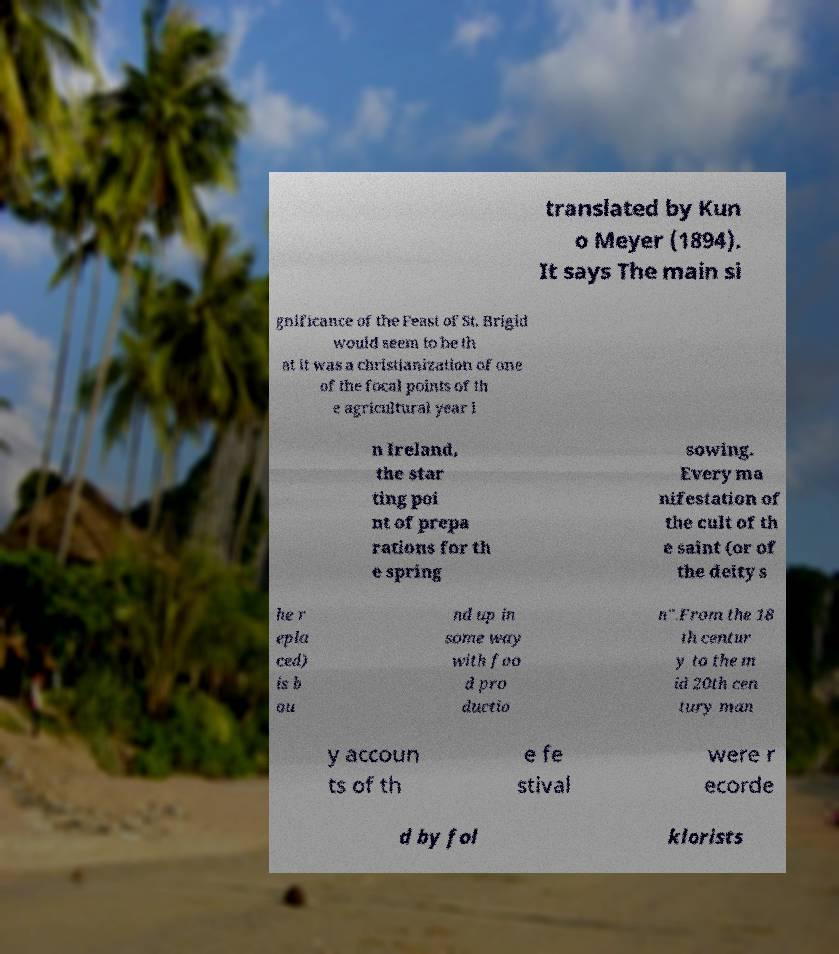I need the written content from this picture converted into text. Can you do that? translated by Kun o Meyer (1894). It says The main si gnificance of the Feast of St. Brigid would seem to be th at it was a christianization of one of the focal points of th e agricultural year i n Ireland, the star ting poi nt of prepa rations for th e spring sowing. Every ma nifestation of the cult of th e saint (or of the deity s he r epla ced) is b ou nd up in some way with foo d pro ductio n".From the 18 th centur y to the m id 20th cen tury man y accoun ts of th e fe stival were r ecorde d by fol klorists 